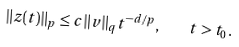<formula> <loc_0><loc_0><loc_500><loc_500>\| z ( t ) \| _ { p } \leq c \| v \| _ { q } t ^ { - d / p } , \quad t > t _ { 0 } .</formula> 